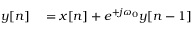<formula> <loc_0><loc_0><loc_500><loc_500>\begin{array} { r l } { y [ n ] } & = x [ n ] + e ^ { + j \omega _ { 0 } } y [ n - 1 ] } \end{array}</formula> 